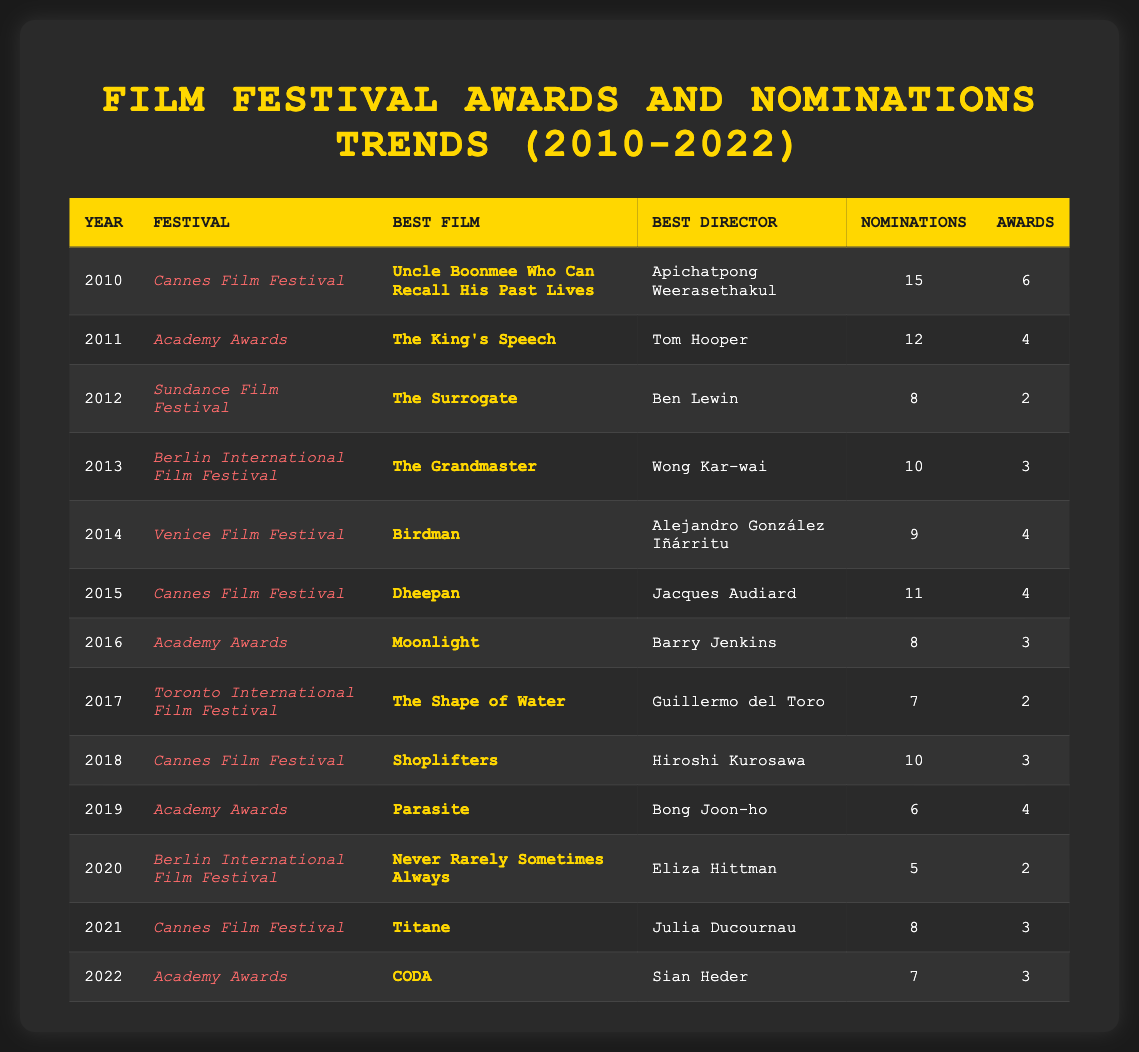What film won the Best Film award at the Academy Awards in 2011? Referring to the table, in the year 2011 under the Academy Awards, the highlighted Best Film is "The King's Speech."
Answer: The King's Speech How many total nominations did the Cannes Film Festival receive in 2018? The table shows that in 2018, the Cannes Film Festival had a total of 10 nominations.
Answer: 10 Which film received the highest number of nominations and how many? Scanning through the table, the film with the highest nominations is "Uncle Boonmee Who Can Recall His Past Lives" with 15 nominations in 2010.
Answer: Uncle Boonmee Who Can Recall His Past Lives, 15 What is the total number of awards won by films at the Berlin International Film Festival from 2013 to 2020? Adding the awards from Berlin International Film Festival across the years: 3 (2013) + 2 (2020) = 5.
Answer: 5 Did any film win more awards than nominations in 2012? For the year 2012, "The Surrogate" received 8 nominations and won only 2 awards, which is not greater than the nominations.
Answer: No Which film won Best Director at the 2014 Venice Film Festival and how many awards did it win? According to the table, "Birdman" was awarded Best Director to Alejandro González Iñárritu at the Venice Film Festival in 2014, and it won 4 awards.
Answer: Birdman, 4 What is the average number of awards won by films at the Academy Awards from 2011 to 2022? The awards from these years are: 4 (2011) + 3 (2016) + 4 (2019) + 3 (2022) = 14 total awards; dividing by the 4 occurrences gives 14/4 = 3.5.
Answer: 3.5 Which festival had the least number of nominations in total across all years and what was the count? Summing up the nominations from each festival, Berlin International Film Festival had the least total nominations with 5 in 2020.
Answer: Berlin International Film Festival, 5 What was the year with the highest number of awards for the Cannes Film Festival? Referring to the table, the Cannes Film Festival received the highest awards in 2010 with 6 awards for "Uncle Boonmee Who Can Recall His Past Lives."
Answer: 2010, 6 How many more awards did "Parasite" win than "Shoplifters"? "Parasite" won 4 awards in 2019, while "Shoplifters" won 3 awards in 2018; thus, the difference is 4 - 3 = 1.
Answer: 1 How many films won the Best Film award at the Academy Awards from 2010 to 2022? Reviewing the table, the films that won Best Film at the Academy Awards are "The King's Speech," "Moonlight," "Parasite," and "CODA," totaling 4 films.
Answer: 4 